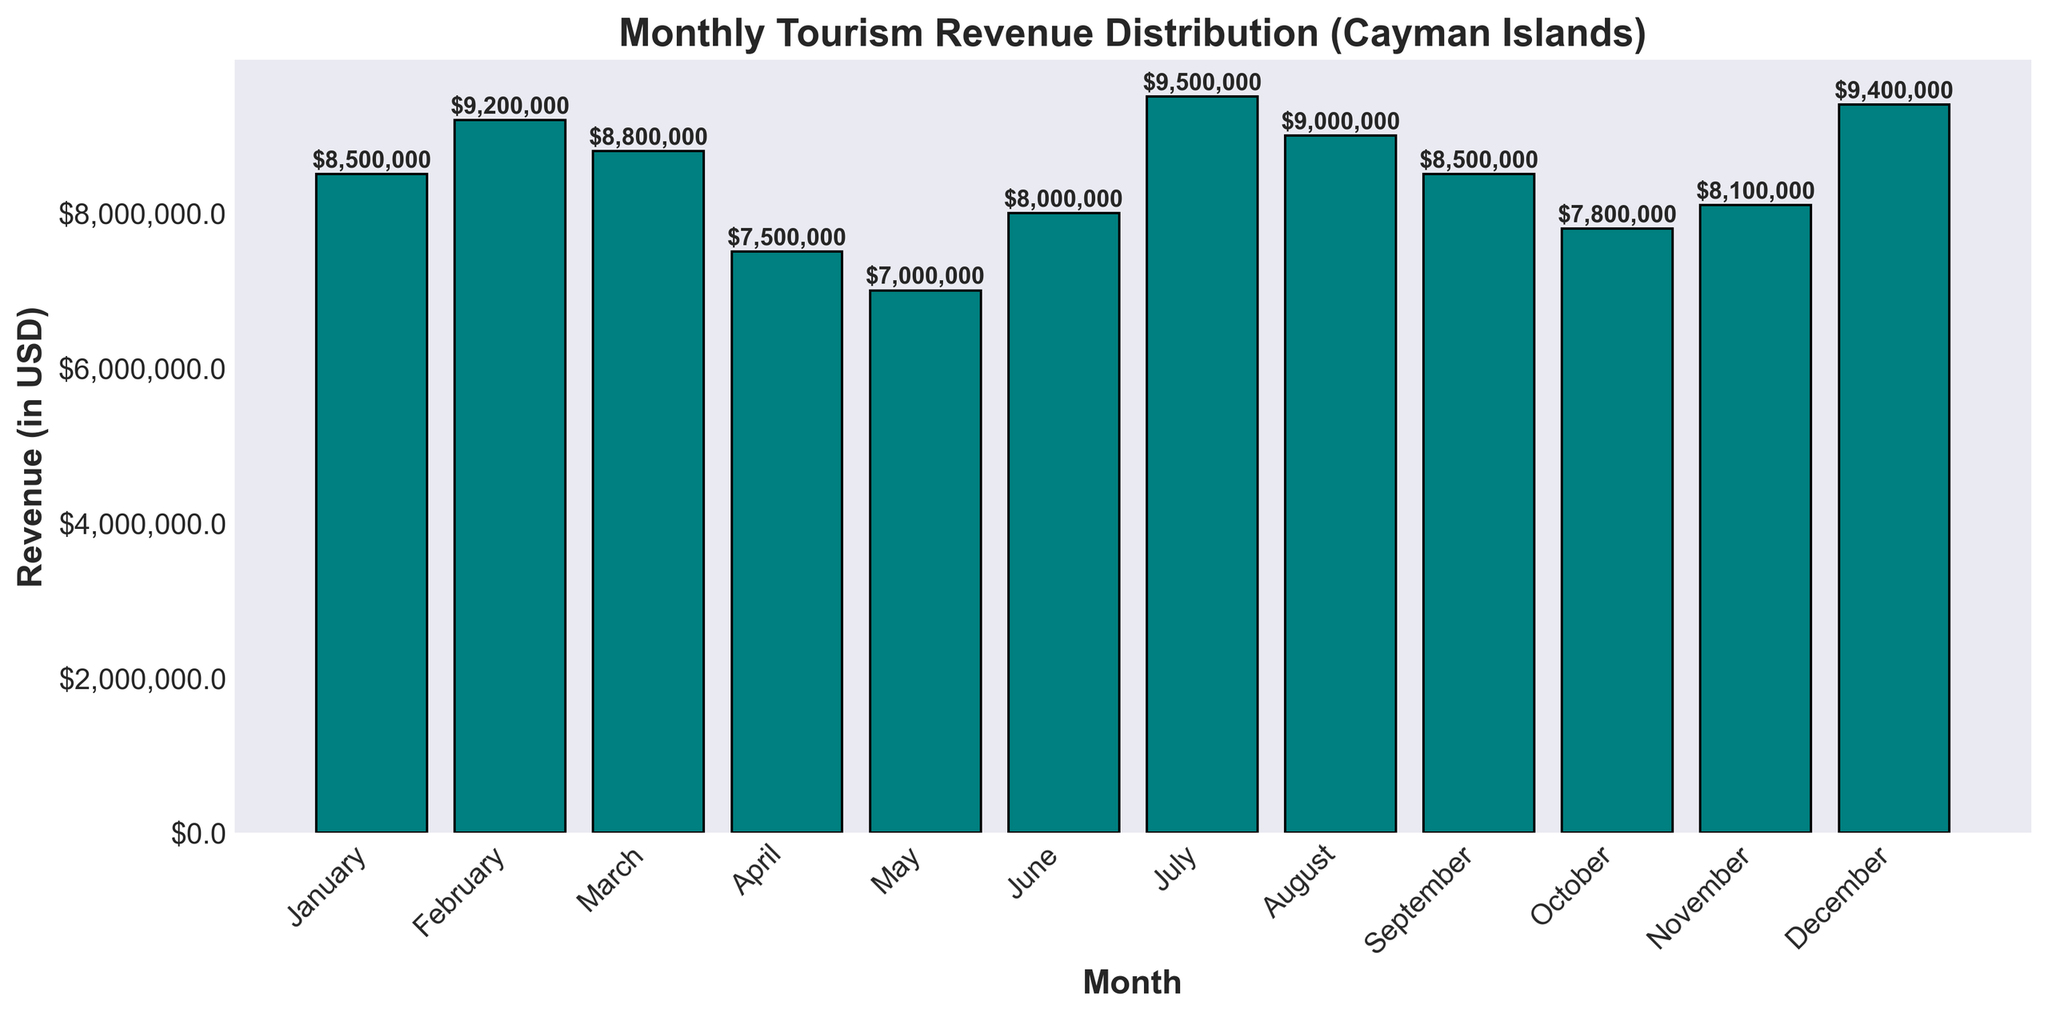Which month has the highest tourism revenue? To find the highest tourism revenue month, observe the bar chart and identify the bar that reaches the highest on the y-axis. The bar representing July is the highest.
Answer: July Which month has the lowest tourism revenue? To determine the lowest tourism revenue month, look for the shortest bar in the chart. The bar for May is the shortest.
Answer: May How does the revenue in February compare to the revenue in April? Compare the heights of the bars representing February and April. The bar for February is higher than the bar for April.
Answer: February has higher revenue What is the total tourism revenue for the first quarter (January to March)? Add the revenues of January, February, and March: $8,500,000 + $9,200,000 + $8,800,000. The total is $26,500,000.
Answer: $26,500,000 What is the average monthly tourism revenue? Add the revenues for all months and divide by 12. The total revenue is $85,300,000, so the average is $85,300,000/12. The average monthly revenue is about $7,108,333.
Answer: $7,108,333 Which months have a revenue exactly equal to $8,500,000? Look for bars reaching the $8,500,000 mark on the y-axis. Both January and September have this revenue.
Answer: January and September What is the difference in revenue between the highest and the lowest month? Subtract the revenue of the lowest month (May, $7,000,000) from the highest month (July, $9,500,000). The difference is $2,500,000.
Answer: $2,500,000 How many months have a revenue greater than $9,000,000? Count the bars that exceed the $9,000,000 mark on the y-axis. The months are February, July, August, and December, making a total of 4 months.
Answer: 4 months Which quarter of the year has the highest total revenue? Calculate the total revenue for each quarter and compare. Q1 (Jan-Mar): $26,500,000, Q2 (Apr-Jun): $22,500,000, Q3 (Jul-Sep): $27,000,000, Q4 (Oct-Dec): $25,300,000. Q3 has the highest total revenue.
Answer: Q3 What is the combined revenue for June and December? Add the revenues of June and December: $8,000,000 + $9,400,000. The total is $17,400,000.
Answer: $17,400,000 